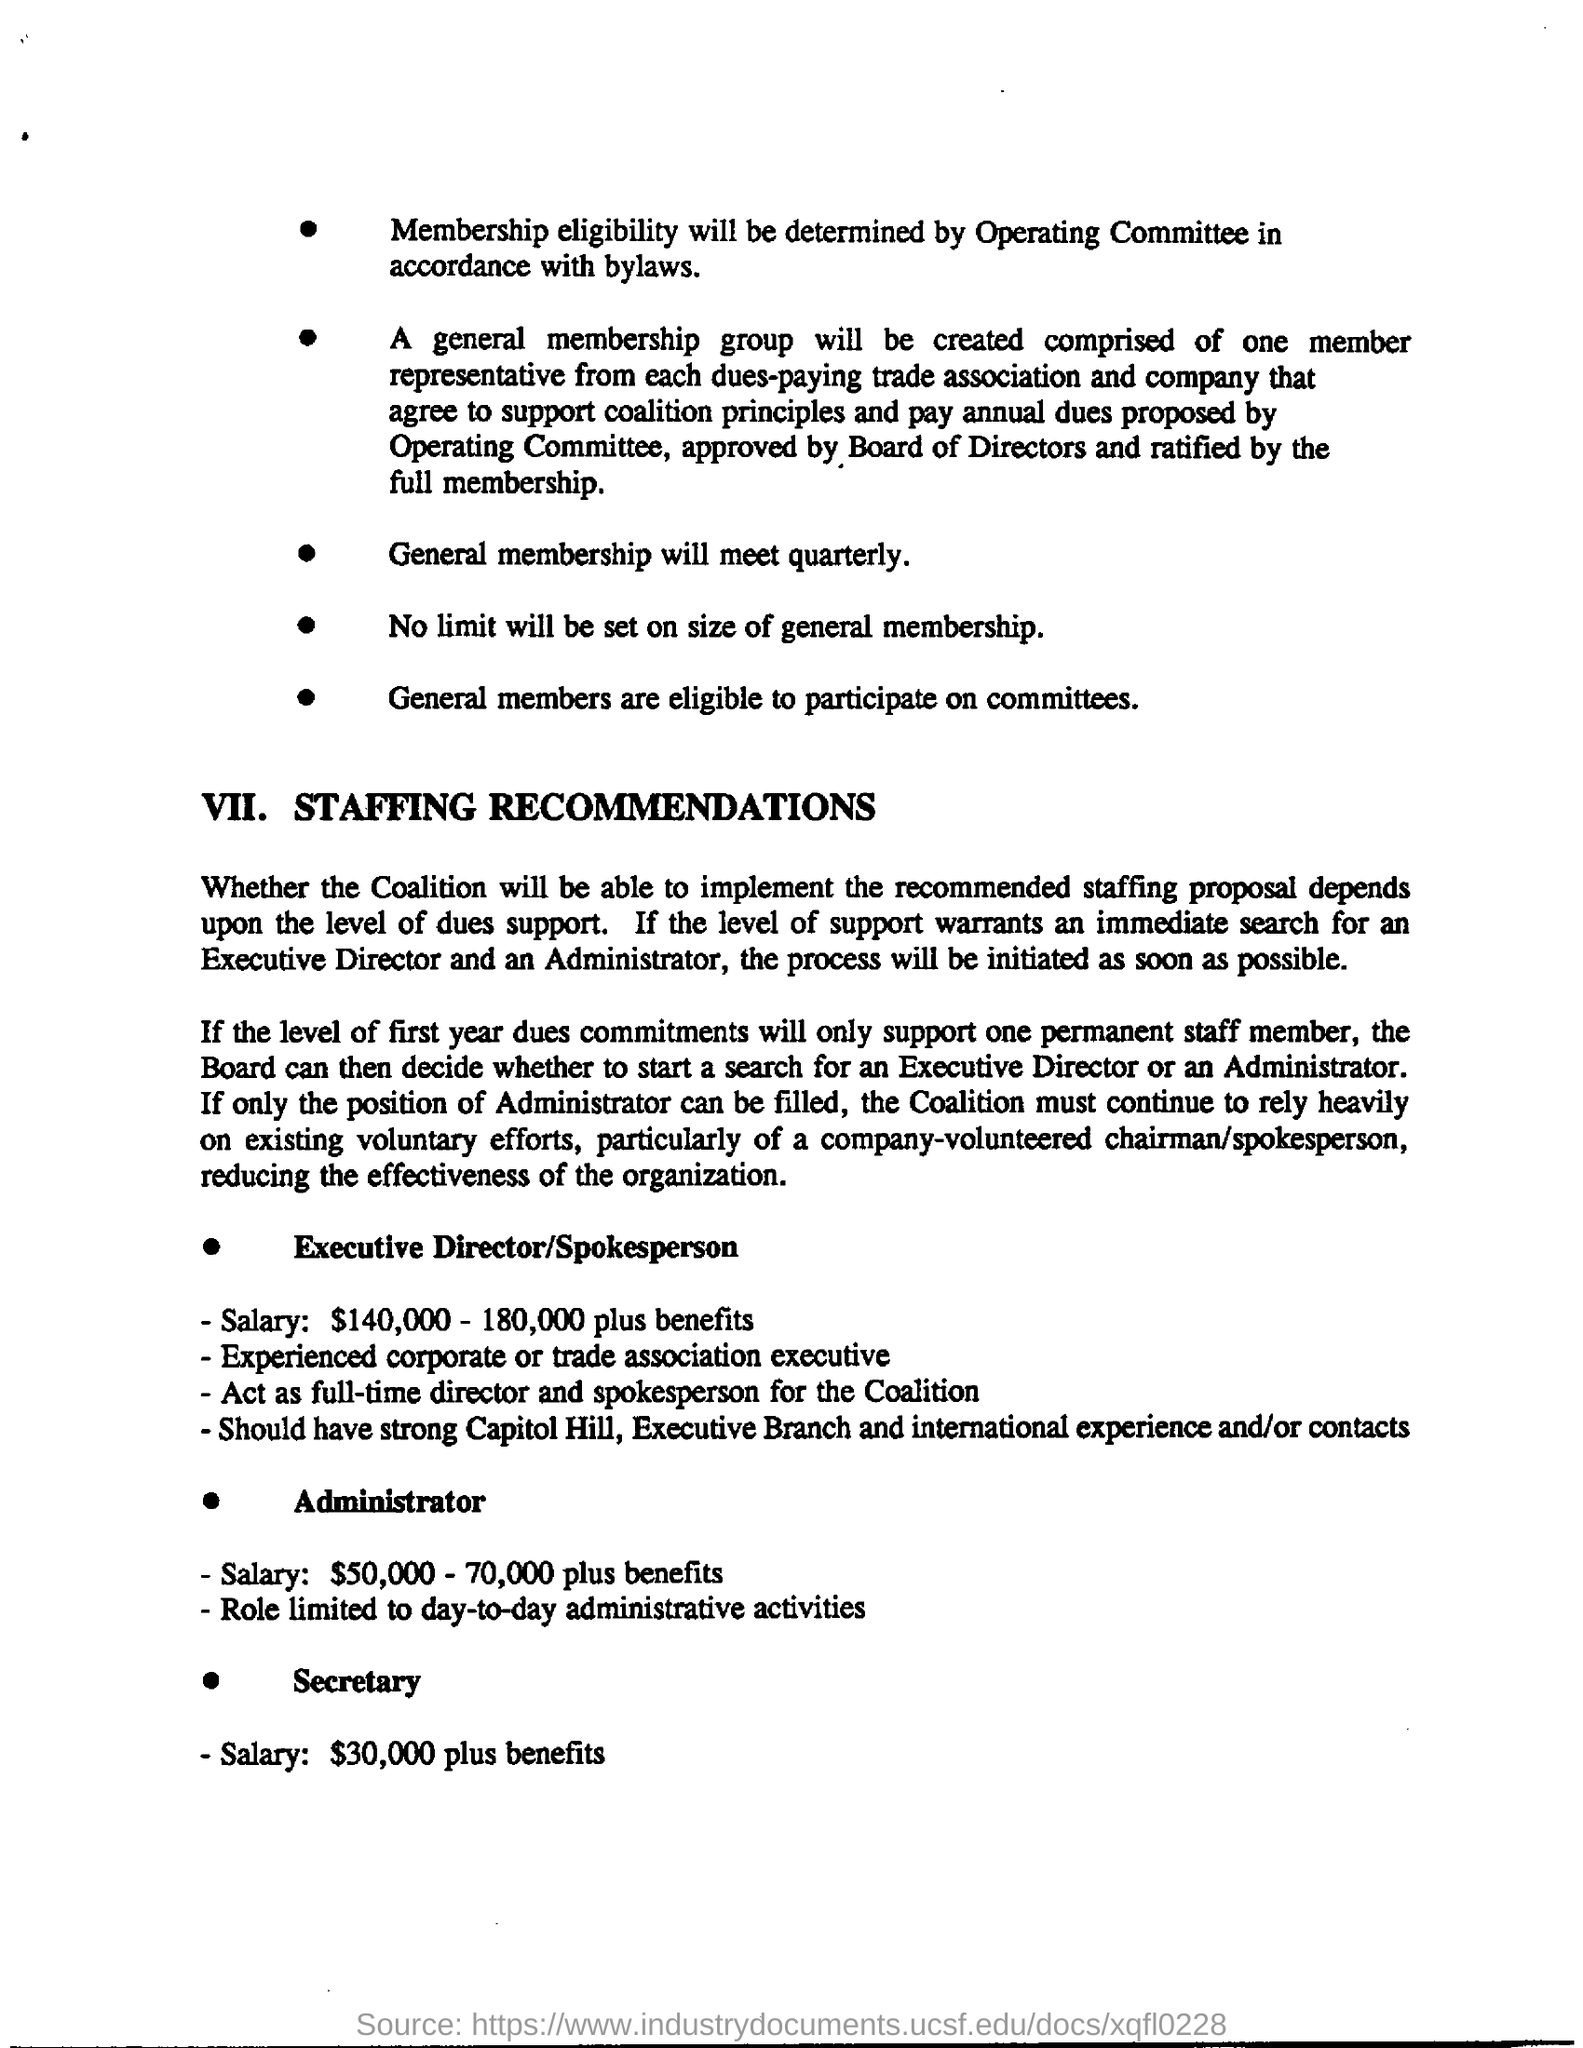Who will determine the membership eligibility?
Your answer should be very brief. By operating committee in accordance with bylaws. When will general membership meet?
Offer a very short reply. General membership will meet quarterly. Is there a limit on the size of general membership?
Keep it short and to the point. No. Who gets the highest salary plus benefits?
Your response must be concise. Executive Director/Spokesperson. What is administrator's role limited to?
Your response must be concise. Day-to-day administrative activities. What salary will Secretary get?
Offer a very short reply. $30,000 plus benefits. 